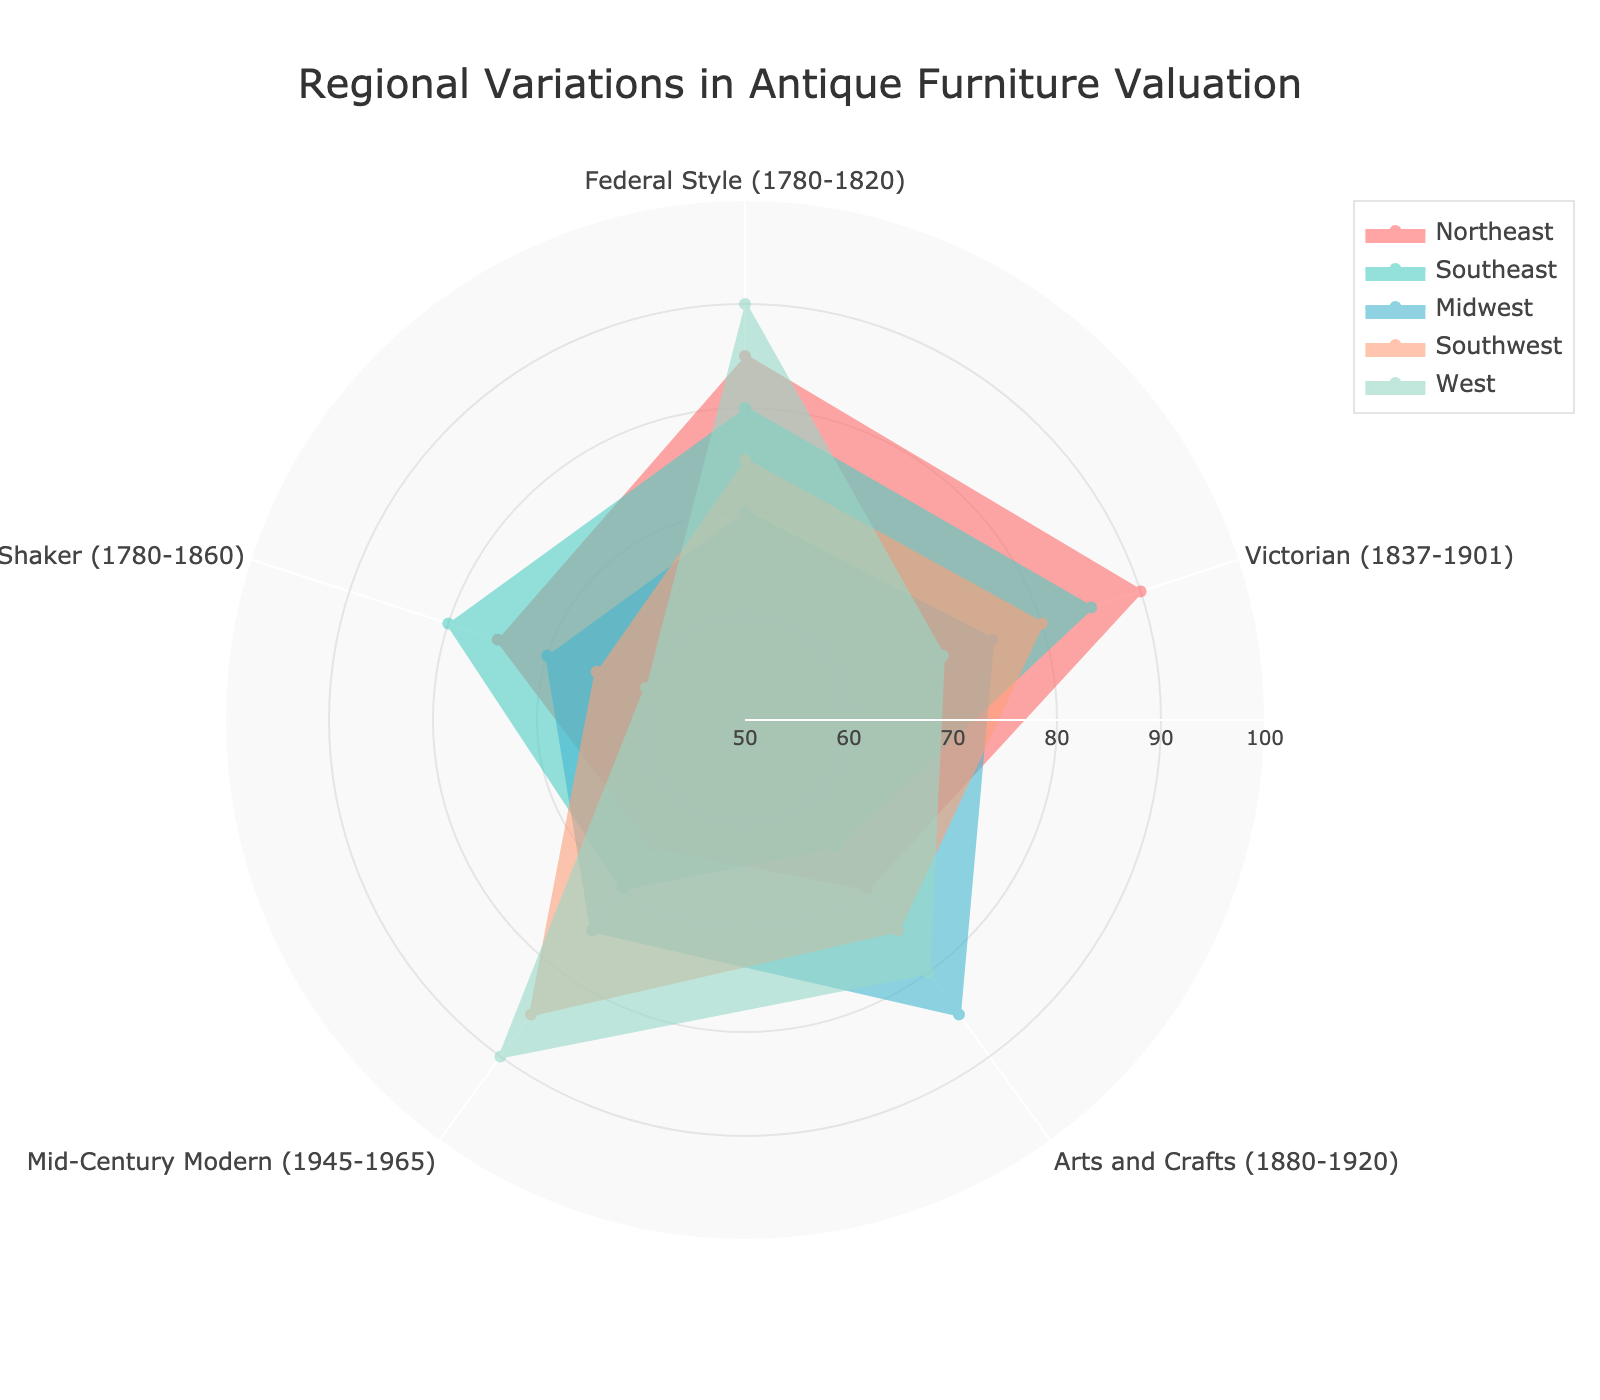What are the categories shown in the radar chart? The categories are the different styles of antique furniture evaluated in the radar chart. They are Federal Style (1780-1820), Victorian (1837-1901), Arts and Crafts (1880-1920), Mid-Century Modern (1945-1965), and Shaker (1780-1860).
Answer: Federal Style, Victorian, Arts and Crafts, Mid-Century Modern, Shaker Which region has the highest valuation for Mid-Century Modern furniture? To find this, observe the Mid-Century Modern (1945-1965) points on the radar chart for all regions. The West region reaches 90, which is the highest value among other regions.
Answer: West What is the title of the radar chart? The title is usually prominently displayed at the top of the chart. It states the purpose of the chart in a concise manner. Here, it is 'Regional Variations in Antique Furniture Valuation.'
Answer: Regional Variations in Antique Furniture Valuation Which category shows the highest valuation for the Northeast region? Check the points for the Northeast region in all categories. The Victorian category reaches 90, which is the highest for the Northeast.
Answer: Victorian Compare the valuation of Shaker furniture in the Southeast and Midwest regions. Which one has a higher value? Locate the Shaker (1780-1860) point for both Southeast and Midwest regions. The Southeast has a value of 80, whereas the Midwest has 70. Therefore, the Southeast valuation is higher.
Answer: Southeast Which region shows the lowest valuation for Shaker furniture? For the Shaker category, observe all regions’ values. The West has the lowest value at 60.
Answer: West Calculate the average valuation of Arts and Crafts furniture across all regions. To find the average, sum up the valuations of all regions for Arts and Crafts: (70 + 65 + 85 + 75 + 80) = 375. Then, divide by the number of regions (5) to get 75.
Answer: 75 What is the difference in valuation for Victorian furniture between the Northeast and West regions? Check the valuation for Victorian (1837-1901) in both Northeast and West regions. The values are 90 and 70, respectively. Subtract the West's value from the Northeast's value: 90 - 70 = 20.
Answer: 20 